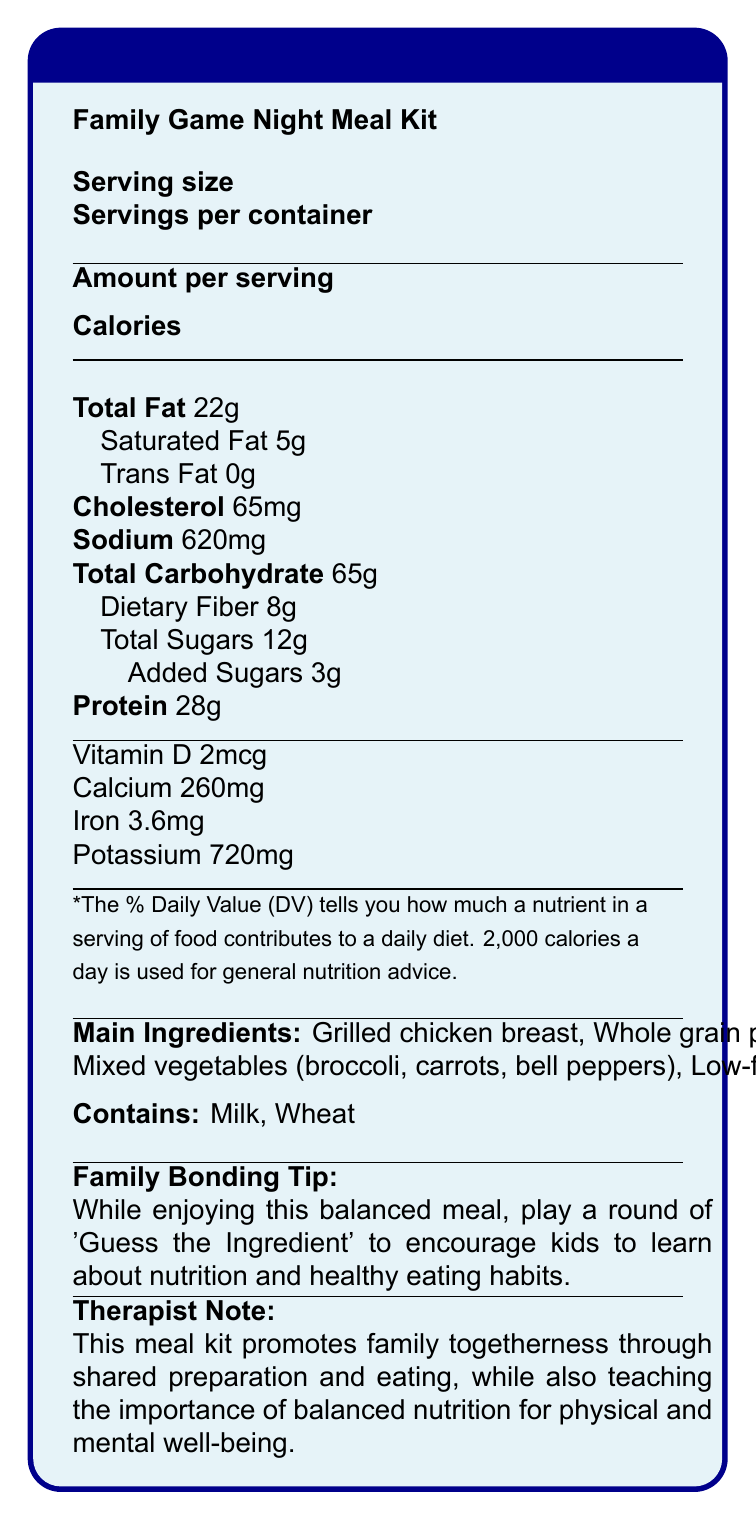what is the serving size for the Family Game Night Meal Kit? The serving size is mentioned at the beginning of the document under the "Serving size" section.
Answer: 1 plate (450g) how many servings are there per container of the meal kit? The document lists the number of servings per container as 4.
Answer: 4 what is the amount of protein per serving? The amount of protein per serving is shown in the nutritional breakdown as 28 grams.
Answer: 28g which allergens are present in the Family Game Night Meal Kit? The allergens are listed at the bottom of the document under "Contains".
Answer: Milk and Wheat how much dietary fiber is in one serving, and what percentage of the daily value does it represent? The dietary fiber content is listed as 8 grams and represents 29% of the daily value.
Answer: 8g, 29% what is the main idea of the document? The document contains a nutrition facts label, main ingredients, allergens, a family bonding tip, and a therapist note, all focusing on the importance of balanced nutrition and family togetherness.
Answer: It provides detailed nutritional information for the Family Game Night Meal Kit, highlighting balanced nutrition and promoting family bonding through preparation and eating. how much calcium is in one serving of the meal kit? The document lists the calcium content as 260 milligrams per serving.
Answer: 260mg what percentage of the daily value of sodium does one serving of the meal kit provide? The document lists the sodium content as providing 27% of the daily value.
Answer: 27% which of the following ingredients is not listed as part of the meal kit? A. Grilled Chicken Breast B. Whole Grain Bread C. Mixed Vegetables D. Low-fat Cheese Sauce The provided ingredients are Grilled Chicken Breast, Whole Grain Pasta, Mixed Vegetables, and Low-fat Cheese Sauce. Whole Grain Bread is not listed.
Answer: B. Whole Grain Bread what is the family bonding tip included on the document? The tip encourages families to play a game while enjoying their meal to foster learning and bonding.
Answer: Play a round of 'Guess the Ingredient' to encourage kids to learn about nutrition and healthy eating habits. does the meal kit contain any trans fat? The document specifies that the trans fat content is 0 grams.
Answer: No what is the therapist note about? The therapist emphasizes the dual focus on family bonding and the educational aspect of understanding balanced nutrition.
Answer: The meal kit promotes family togetherness through shared preparation and eating, while teaching the importance of balanced nutrition. how many calories are in one serving of the Family Game Night Meal Kit? The calorie count per serving is highlighted at the top of the nutritional information as 550 calories.
Answer: 550 which vitamin is included in the meal kit, and what percentage of the daily value does it represent? The document lists Vitamin D content as 2mcg, representing 10% of the daily value.
Answer: Vitamin D, 10% what are the main ingredients of the Family Game Night Meal Kit? The document lists these ingredients under the "Main Ingredients" section.
Answer: Grilled chicken breast, Whole grain pasta, Mixed vegetables (broccoli, carrots, bell peppers), Low-fat cheese sauce what is the suggested use of the meal kit mentioned in the game night theme? A. Quick snack B. Balanced meal for sustained energy C. Dessert D. Breakfast The document mentions that the meal is designed to provide sustained energy for an evening of family gaming.
Answer: B. Balanced meal for sustained energy summarize the main nutritional benefits of the Family Game Night Meal Kit. The meal kit's nutritional profile includes proteins, fiber, essential vitamins, and minerals, designed to sustain energy and promote balanced nutrition.
Answer: The meal kit offers a balanced nutritional profile with proteins, complex carbohydrates, vegetables, and essential vitamins and minerals to sustain energy and promote healthy eating habits. how much added sugar does the meal kit contain? The document shows that added sugars are 3 grams per serving.
Answer: 3g is the Family Game Night Meal Kit gluten-free? The document lists wheat as an allergen, indicating that the meal kit contains gluten.
Answer: No how much iron does one serving of the meal kit provide, and what is its percentage of the daily value? The document lists the iron content as 3.6 milligrams, which represents 20% of the daily value.
Answer: 3.6mg, 20% how much total carbohydrate does one serving of the meal kit contain? The total carbohydrate content for one serving is listed as 65 grams.
Answer: 65g what is the total percentage of daily value of fats (Total Fat and Saturated Fat) in one serving? The percentage of daily value for Total Fat is 28%, and for Saturated Fat is 25%, summing to a total of 53%.
Answer: 53% (28% Total Fat + 25% Saturated Fat) how does the meal kit promote family togetherness? The therapist note and family bonding tip emphasize shared activities and educational games to promote family togetherness.
Answer: Through shared preparation and eating, and educational activities like 'Guess the Ingredient'. who is the meal kit intended for? The document emphasizes the family game night theme, indicating it is intended for families.
Answer: Families looking for a balanced meal to enjoy during game night. 